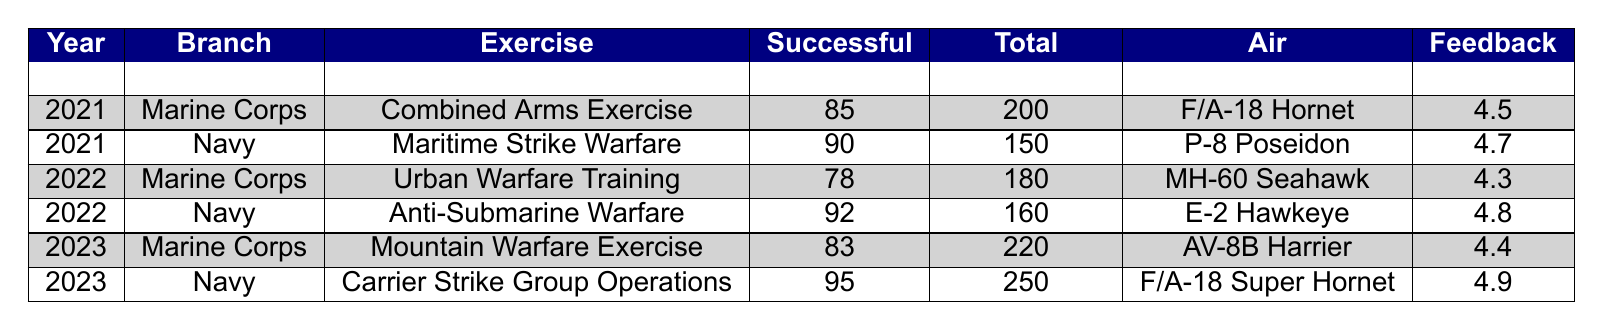What was the successful outcome percentage for the Marine Corps in 2021? The successful outcome for the Marine Corps in 2021 was 85 out of 200 participants. To find the percentage, divide 85 by 200 and multiply by 100: (85/200) * 100 = 42.5%.
Answer: 42.5% What exercise did the Navy conduct in 2022? The data shows that in 2022, the Navy conducted the "Anti-Submarine Warfare" exercise.
Answer: Anti-Submarine Warfare Which year had the highest feedback score for a Marine Corps exercise? By checking the feedback scores for Marine Corps exercises, we find that 2021 had a feedback score of 4.5, 2022 had 4.3, and 2023 had 4.4. The highest score is 4.5 in 2021.
Answer: 2021 What is the average successful outcomes across all exercises in 2023? The successful outcomes in 2023 were 83 for the Marine Corps and 95 for the Navy. To find the average: (83 + 95) / 2 = 89.
Answer: 89 Did the Navy's Maritime Strike Warfare exercise have more successful outcomes than the Marine Corps' Urban Warfare Training in 2022? The Navy's Maritime Strike Warfare exercise in 2021 had 90 successful outcomes, while the Marine Corps' Urban Warfare Training in 2022 had 78 successful outcomes. Since 90 is greater than 78, the statement is true.
Answer: Yes Which branch had a better feedback score in 2022? In 2022, the Marine Corps received a feedback score of 4.3, while the Navy received a score of 4.8. Since 4.8 is higher than 4.3, the Navy had a better feedback score.
Answer: Navy What was the total number of participants in the Carrier Strike Group Operations exercise? According to the table, the Carrier Strike Group Operations exercise conducted by the Navy in 2023 had 250 participants.
Answer: 250 Is the success rate of the Navy in 2022 higher than the Marine Corps in 2021? The Navy's successful outcomes in 2022 were 92 (exercise not listed, but in the Navy's entry) and the Marine Corps had 85 in 2021. By checking the figures, 92 is indeed higher than 85.
Answer: Yes What is the difference in successful outcomes between the Marine Corps and Navy for their exercises in 2023? In 2023, the Marine Corps had 83 successful outcomes and the Navy had 95. To find the difference, subtract Marine Corps outcomes from the Navy’s: 95 - 83 = 12.
Answer: 12 